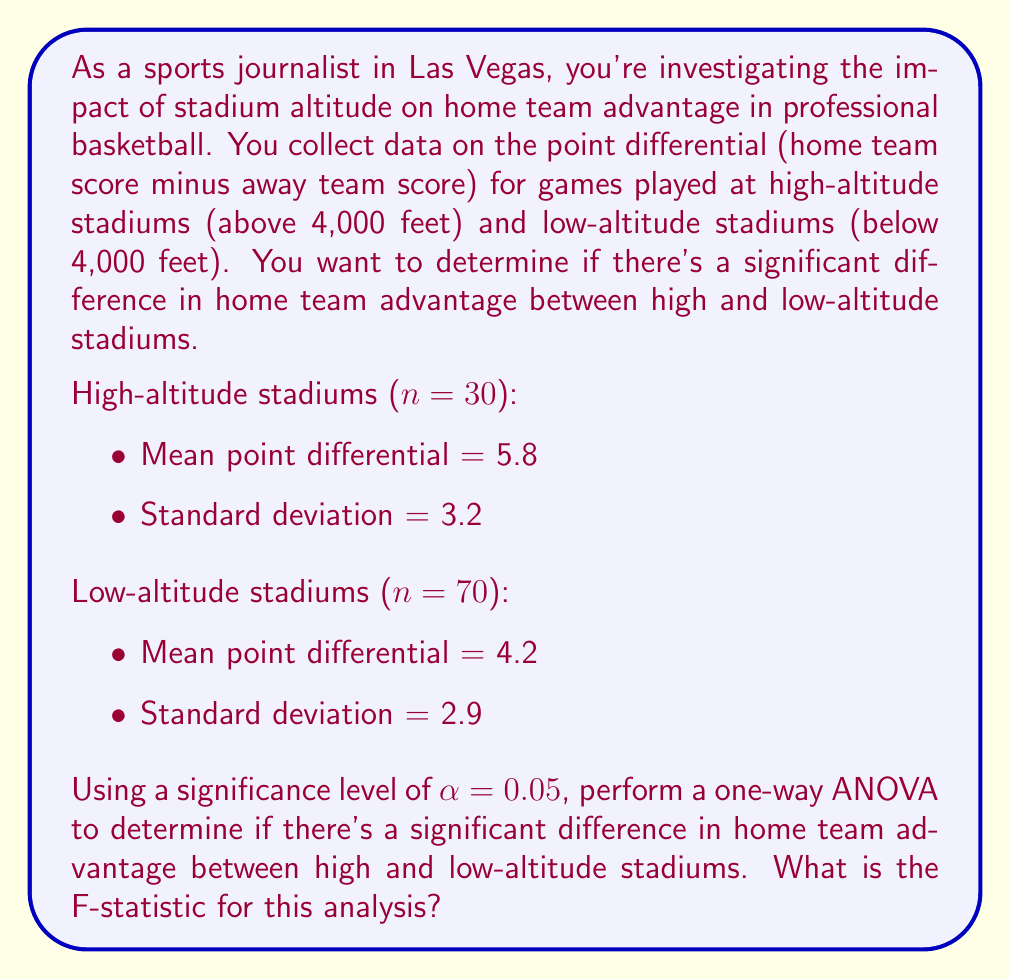Could you help me with this problem? To solve this problem, we'll use a one-way ANOVA (Analysis of Variance) test. Here are the steps:

1. Calculate the overall mean:
   $\bar{X} = \frac{(30 \times 5.8) + (70 \times 4.2)}{100} = 4.68$

2. Calculate the Sum of Squares Between (SSB):
   $$SSB = 30(5.8 - 4.68)^2 + 70(4.2 - 4.68)^2 = 57.12$$

3. Calculate the Sum of Squares Within (SSW):
   $$SSW = (30-1)(3.2)^2 + (70-1)(2.9)^2 = 881.59$$

4. Calculate the Sum of Squares Total (SST):
   $$SST = SSB + SSW = 57.12 + 881.59 = 938.71$$

5. Calculate degrees of freedom:
   - Between groups: $df_B = 2 - 1 = 1$
   - Within groups: $df_W = 100 - 2 = 98$
   - Total: $df_T = 100 - 1 = 99$

6. Calculate Mean Square Between (MSB) and Mean Square Within (MSW):
   $$MSB = \frac{SSB}{df_B} = \frac{57.12}{1} = 57.12$$
   $$MSW = \frac{SSW}{df_W} = \frac{881.59}{98} = 8.996$$

7. Calculate the F-statistic:
   $$F = \frac{MSB}{MSW} = \frac{57.12}{8.996} = 6.35$$

The F-statistic for this analysis is 6.35.
Answer: The F-statistic for this one-way ANOVA analysis is 6.35. 